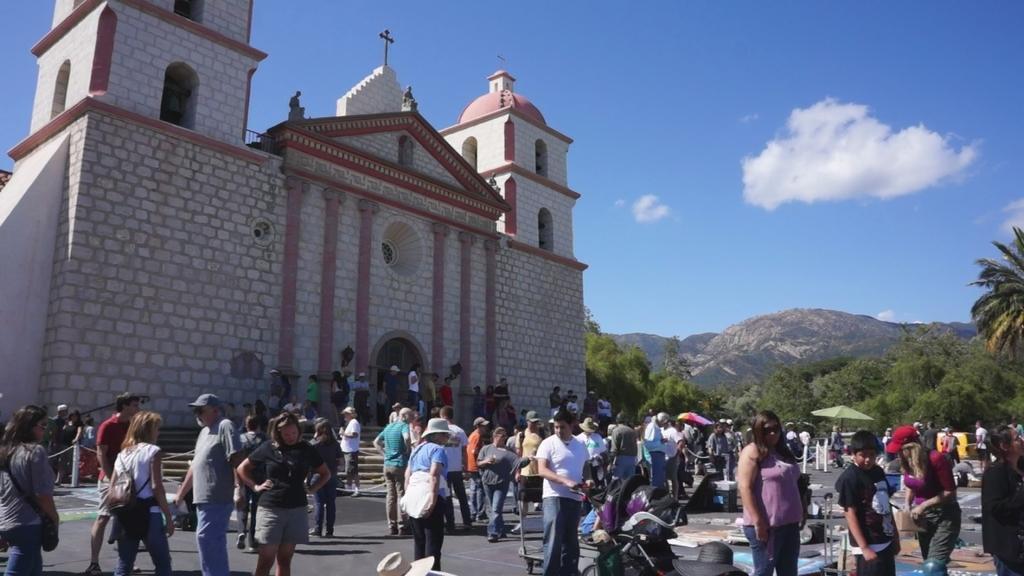Please provide a concise description of this image. In this image there are a group of people standing. Behind the persons we can see a building, group of trees and mountains. At the top we can see the sky. 